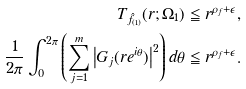Convert formula to latex. <formula><loc_0><loc_0><loc_500><loc_500>T _ { \hat { f } _ { ( 1 ) } } ( r ; \Omega _ { 1 } ) & \leqq r ^ { \rho _ { f } + \epsilon } , \\ \frac { 1 } { 2 \pi } \int _ { 0 } ^ { 2 \pi } \left ( \sum _ { j = 1 } ^ { m } \left | G _ { j } ( r e ^ { i \theta } ) \right | ^ { 2 } \right ) d \theta & \leqq r ^ { \rho _ { f } + \epsilon } .</formula> 